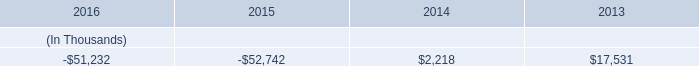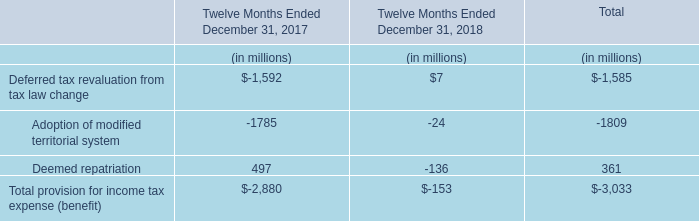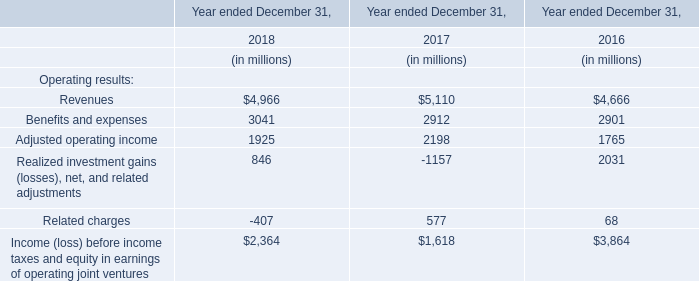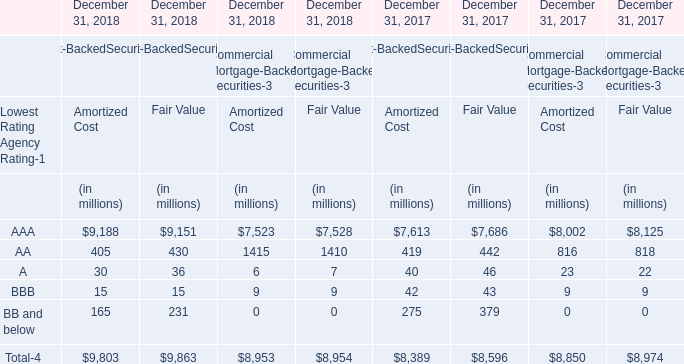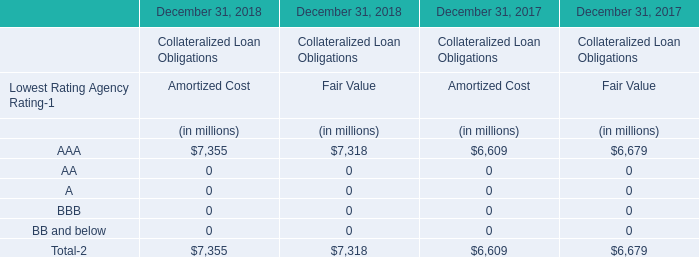What was the total amount of Amortized Cost greater than 10 in 2018 for Commercial Mortgage-Backed Securities-3? (in million) 
Computations: (1415 + 7523)
Answer: 8938.0. 